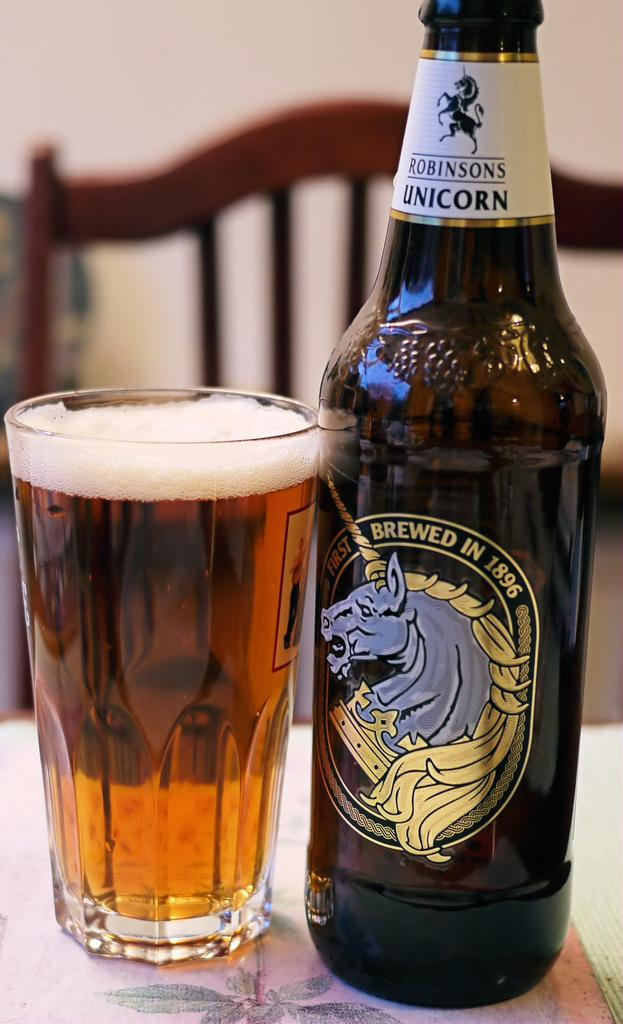<image>
Give a short and clear explanation of the subsequent image. A glass and beer bottle from Robinsons Unicorn 